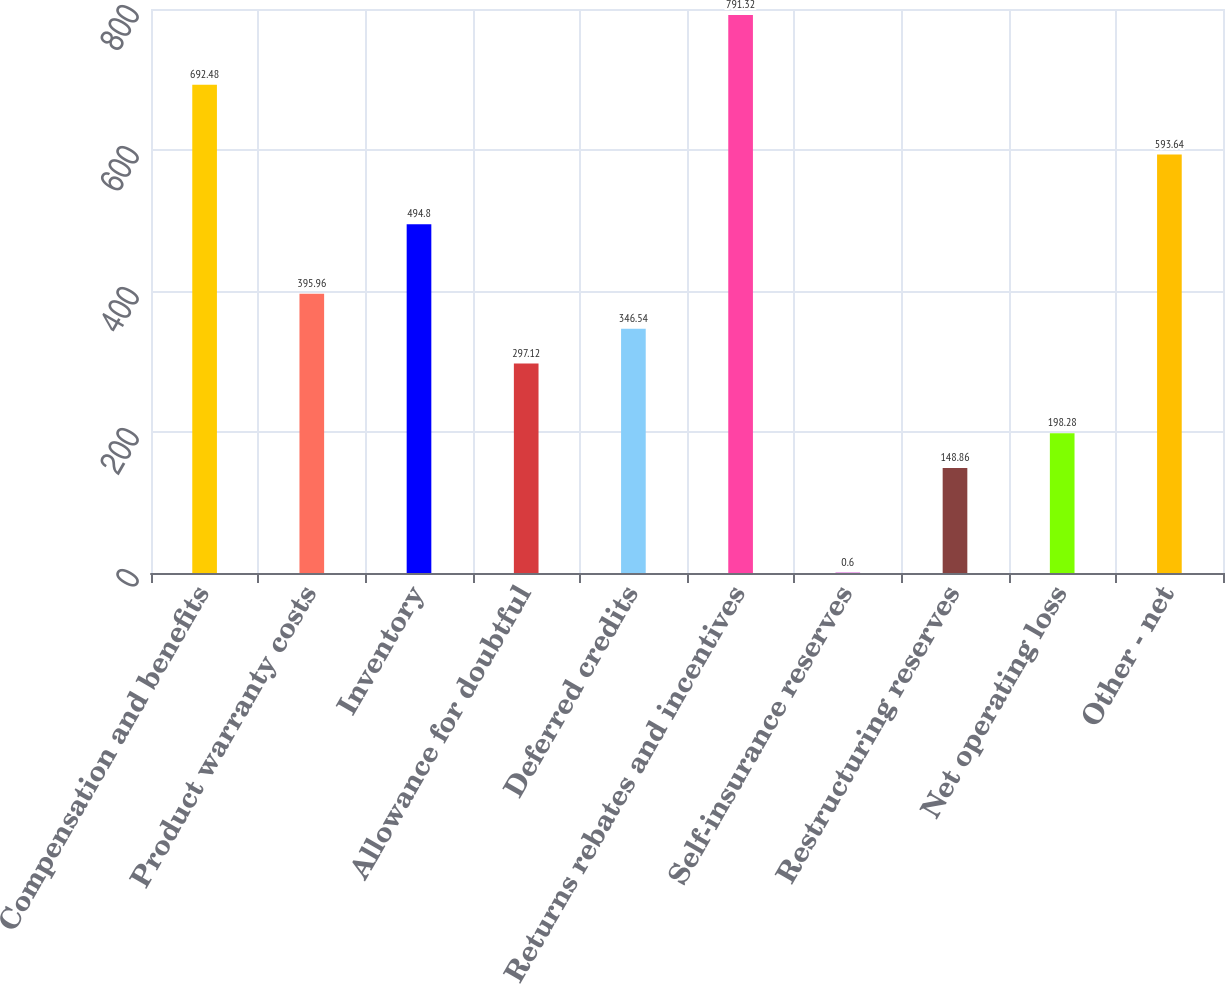<chart> <loc_0><loc_0><loc_500><loc_500><bar_chart><fcel>Compensation and benefits<fcel>Product warranty costs<fcel>Inventory<fcel>Allowance for doubtful<fcel>Deferred credits<fcel>Returns rebates and incentives<fcel>Self-insurance reserves<fcel>Restructuring reserves<fcel>Net operating loss<fcel>Other - net<nl><fcel>692.48<fcel>395.96<fcel>494.8<fcel>297.12<fcel>346.54<fcel>791.32<fcel>0.6<fcel>148.86<fcel>198.28<fcel>593.64<nl></chart> 